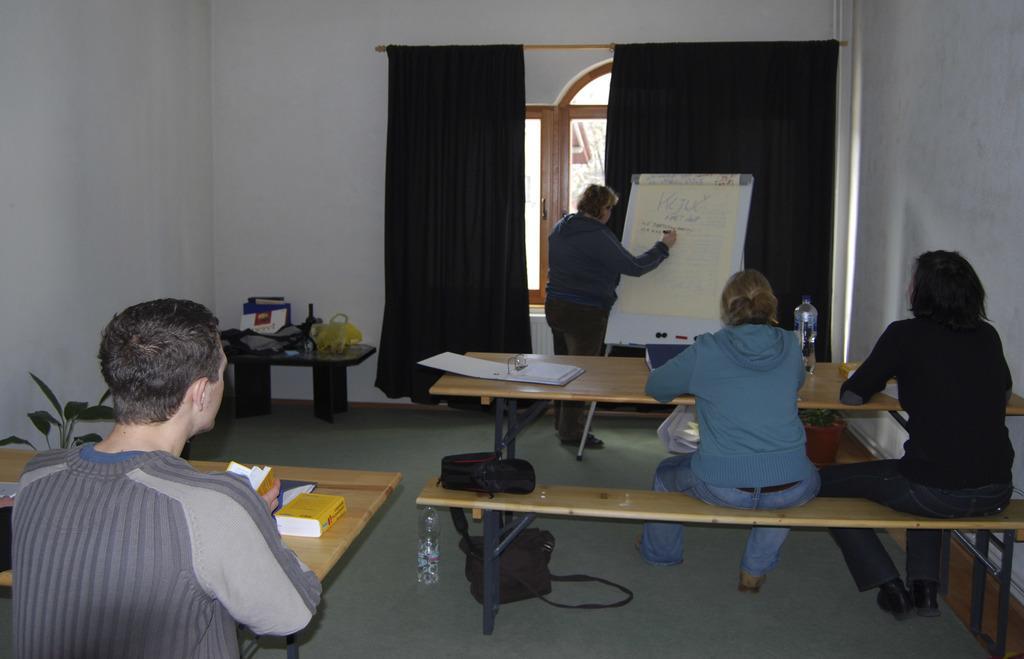In one or two sentences, can you explain what this image depicts? In this image can see a man writing something on the board. Here we can see three persons sitting on a table and they are paying attention to this person. This is a wooden table where a file and a water bottle are kept on it. Here we can see a window which is bounded with a curtain. 